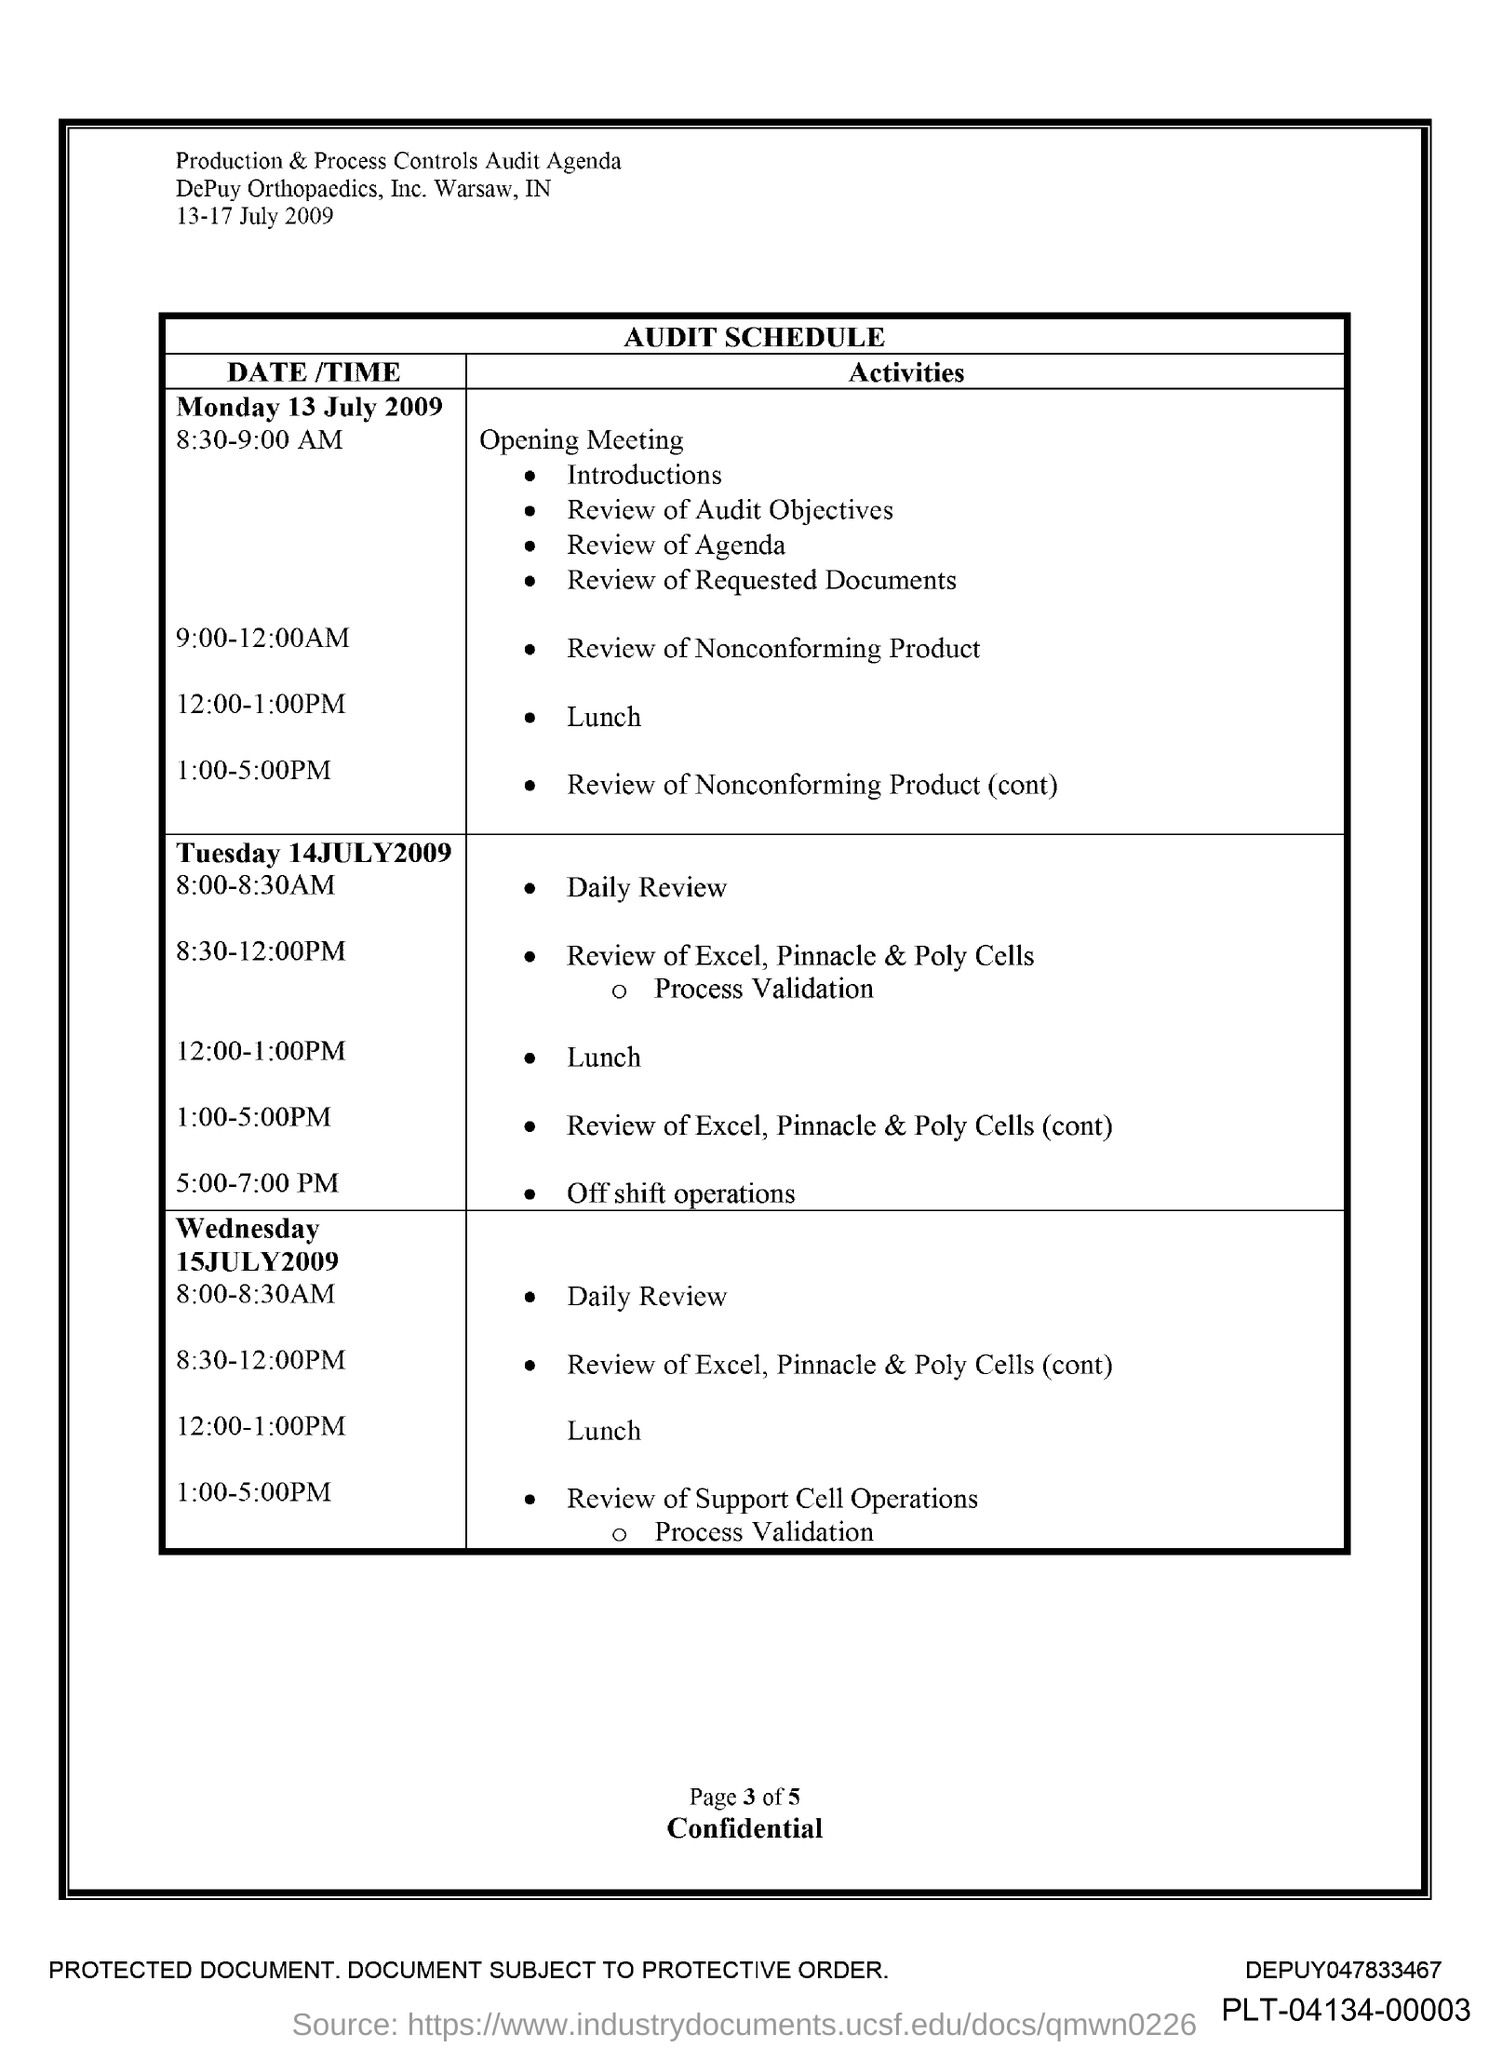What is the Time for Lunch on Monday 13 July 2009 ?
Ensure brevity in your answer.  12:00-1:00PM. What is the time for daily review on Tuesday 14 July 2009?
Your answer should be very brief. 8:00-8:30AM. 